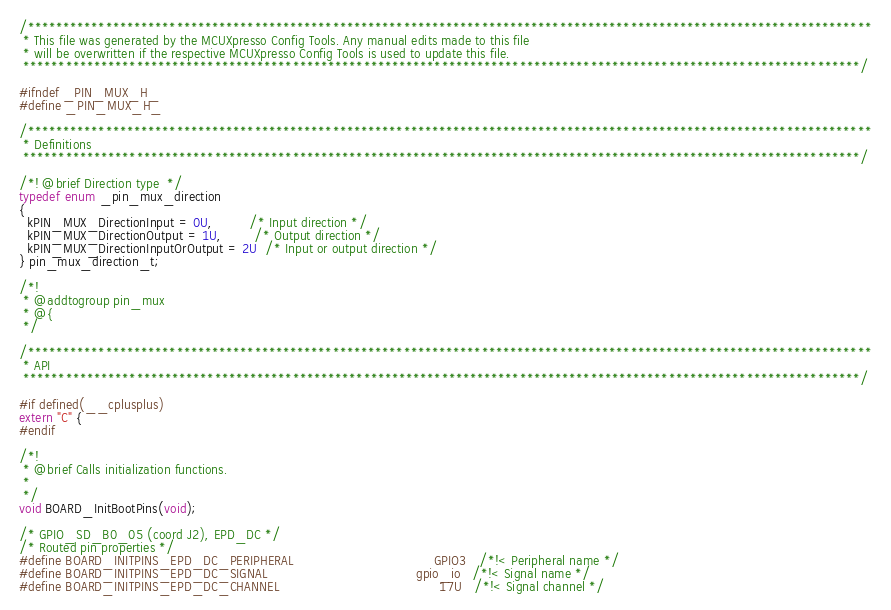<code> <loc_0><loc_0><loc_500><loc_500><_C_>/***********************************************************************************************************************
 * This file was generated by the MCUXpresso Config Tools. Any manual edits made to this file
 * will be overwritten if the respective MCUXpresso Config Tools is used to update this file.
 **********************************************************************************************************************/

#ifndef _PIN_MUX_H_
#define _PIN_MUX_H_

/***********************************************************************************************************************
 * Definitions
 **********************************************************************************************************************/

/*! @brief Direction type  */
typedef enum _pin_mux_direction
{
  kPIN_MUX_DirectionInput = 0U,         /* Input direction */
  kPIN_MUX_DirectionOutput = 1U,        /* Output direction */
  kPIN_MUX_DirectionInputOrOutput = 2U  /* Input or output direction */
} pin_mux_direction_t;

/*!
 * @addtogroup pin_mux
 * @{
 */

/***********************************************************************************************************************
 * API
 **********************************************************************************************************************/

#if defined(__cplusplus)
extern "C" {
#endif

/*!
 * @brief Calls initialization functions.
 *
 */
void BOARD_InitBootPins(void);

/* GPIO_SD_B0_05 (coord J2), EPD_DC */
/* Routed pin properties */
#define BOARD_INITPINS_EPD_DC_PERIPHERAL                                   GPIO3   /*!< Peripheral name */
#define BOARD_INITPINS_EPD_DC_SIGNAL                                     gpio_io   /*!< Signal name */
#define BOARD_INITPINS_EPD_DC_CHANNEL                                        17U   /*!< Signal channel */
</code> 